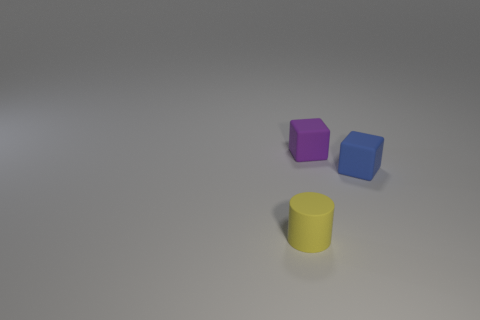Add 2 small rubber cylinders. How many objects exist? 5 Subtract all blue blocks. How many blocks are left? 1 Subtract 1 cylinders. How many cylinders are left? 0 Subtract all cylinders. How many objects are left? 2 Add 2 matte cylinders. How many matte cylinders exist? 3 Subtract 0 red blocks. How many objects are left? 3 Subtract all gray cubes. Subtract all gray spheres. How many cubes are left? 2 Subtract all blue matte objects. Subtract all yellow shiny blocks. How many objects are left? 2 Add 3 tiny matte cubes. How many tiny matte cubes are left? 5 